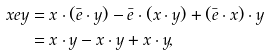Convert formula to latex. <formula><loc_0><loc_0><loc_500><loc_500>x e y & = x \cdot ( \bar { e } \cdot y ) - \bar { e } \cdot ( x \cdot y ) + ( \bar { e } \cdot x ) \cdot y \\ & = x \cdot y - x \cdot y + x \cdot y ,</formula> 